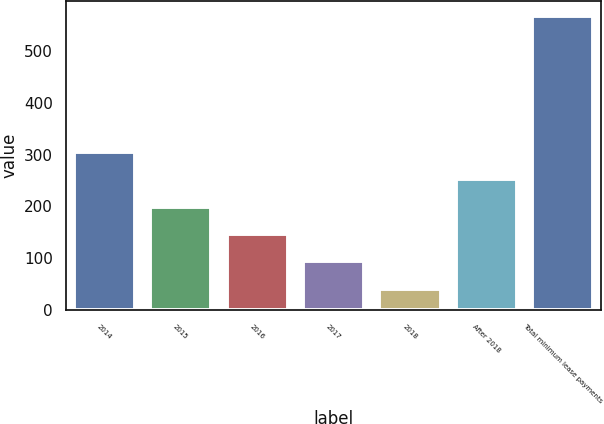Convert chart to OTSL. <chart><loc_0><loc_0><loc_500><loc_500><bar_chart><fcel>2014<fcel>2015<fcel>2016<fcel>2017<fcel>2018<fcel>After 2018<fcel>Total minimum lease payments<nl><fcel>305<fcel>199.4<fcel>146.6<fcel>93.8<fcel>41<fcel>252.2<fcel>569<nl></chart> 